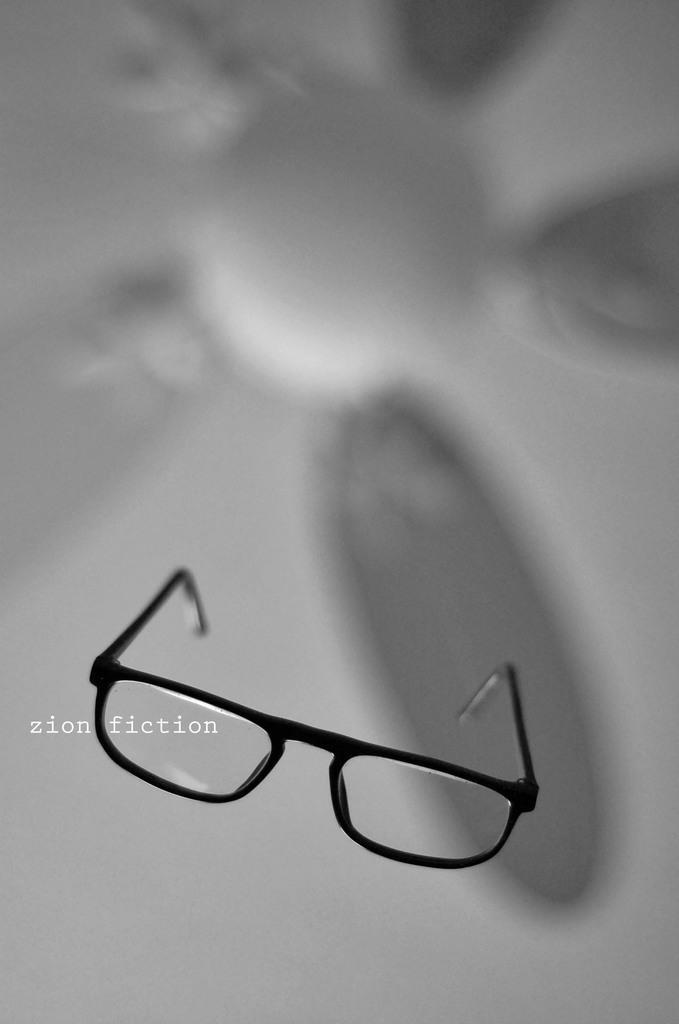How would you summarize this image in a sentence or two? In this image we can see spectacles and a blurry background. 